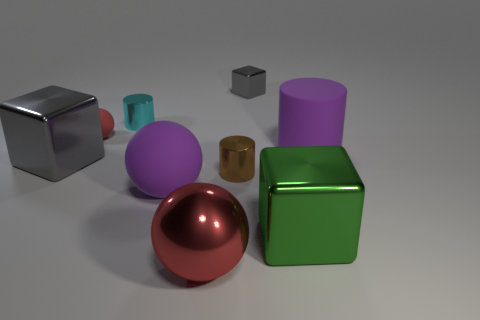Add 1 small cyan things. How many objects exist? 10 Subtract all blocks. How many objects are left? 6 Subtract all large gray things. Subtract all small cyan metallic objects. How many objects are left? 7 Add 3 metallic balls. How many metallic balls are left? 4 Add 2 metallic blocks. How many metallic blocks exist? 5 Subtract 0 cyan balls. How many objects are left? 9 